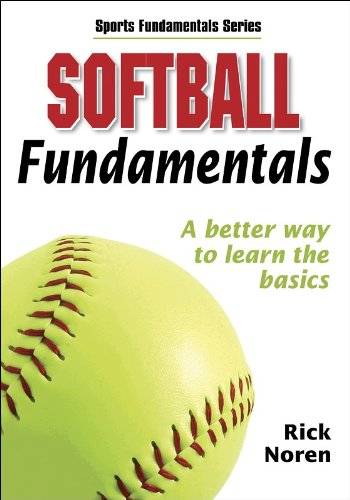Is this book related to Sports & Outdoors? Yes, this book is squarely within the 'Sports & Outdoors' category, providing insights and practical advice on playing softball. 